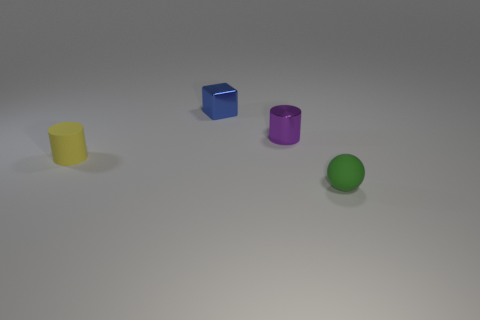Subtract all purple cylinders. How many cylinders are left? 1 Add 2 small gray metallic balls. How many objects exist? 6 Subtract 1 cubes. How many cubes are left? 0 Subtract all spheres. How many objects are left? 3 Subtract all yellow spheres. How many blue cylinders are left? 0 Subtract all cyan shiny spheres. Subtract all tiny green matte objects. How many objects are left? 3 Add 1 small yellow objects. How many small yellow objects are left? 2 Add 3 big metal cylinders. How many big metal cylinders exist? 3 Subtract 0 cyan cylinders. How many objects are left? 4 Subtract all yellow cubes. Subtract all green spheres. How many cubes are left? 1 